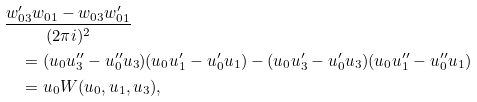Convert formula to latex. <formula><loc_0><loc_0><loc_500><loc_500>& \frac { w _ { 0 3 } ^ { \prime } w _ { 0 1 } - w _ { 0 3 } w _ { 0 1 } ^ { \prime } } { ( 2 \pi i ) ^ { 2 } } \\ & \quad = ( u _ { 0 } u _ { 3 } ^ { \prime \prime } - u _ { 0 } ^ { \prime \prime } u _ { 3 } ) ( u _ { 0 } u _ { 1 } ^ { \prime } - u _ { 0 } ^ { \prime } u _ { 1 } ) - ( u _ { 0 } u _ { 3 } ^ { \prime } - u _ { 0 } ^ { \prime } u _ { 3 } ) ( u _ { 0 } u _ { 1 } ^ { \prime \prime } - u _ { 0 } ^ { \prime \prime } u _ { 1 } ) \\ & \quad = u _ { 0 } W ( u _ { 0 } , u _ { 1 } , u _ { 3 } ) ,</formula> 